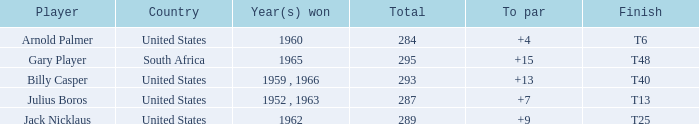Which player from the United States won in 1962? Jack Nicklaus. 